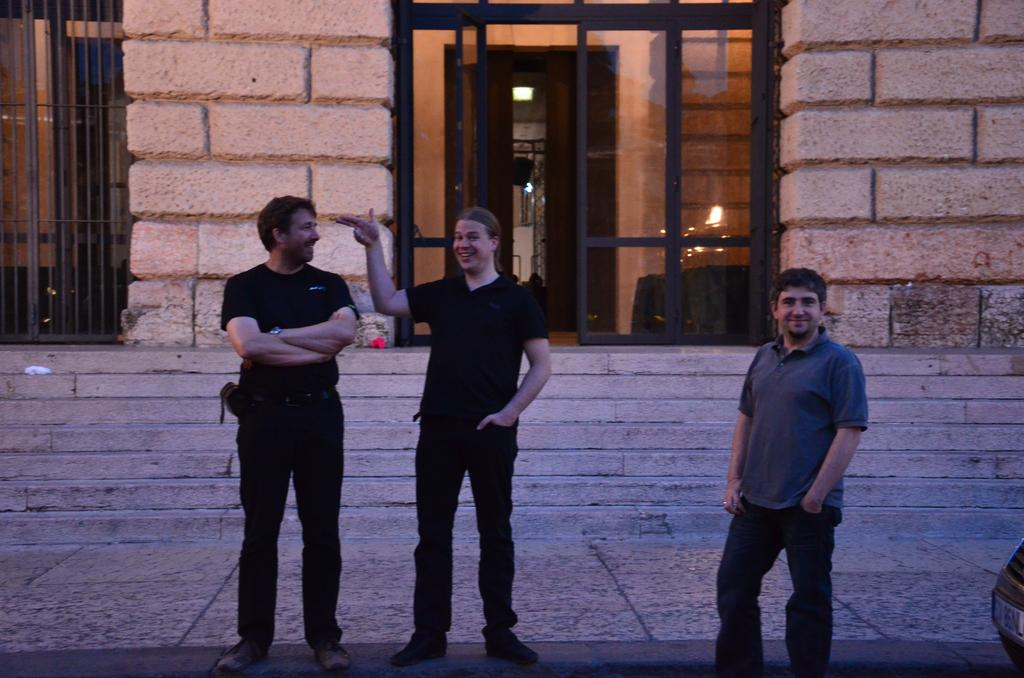How many men are present in the image? There are three men standing on the ground in the image. What type of vehicle can be seen in the image? There is a car in the image. What architectural feature is present in the image? There is a staircase in the image. What type of structure is visible in the image? There is a building with a metal grill in the image. What is a possible entrance to the building in the image? There is a door in the image. What type of barrier is present in the image? There is a wall in the image. Can you tell me how many insects are crawling on the car in the image? There are no insects visible on the car in the image. What type of jar is being used to exchange goods in the image? There is no jar or exchange of goods present in the image. 